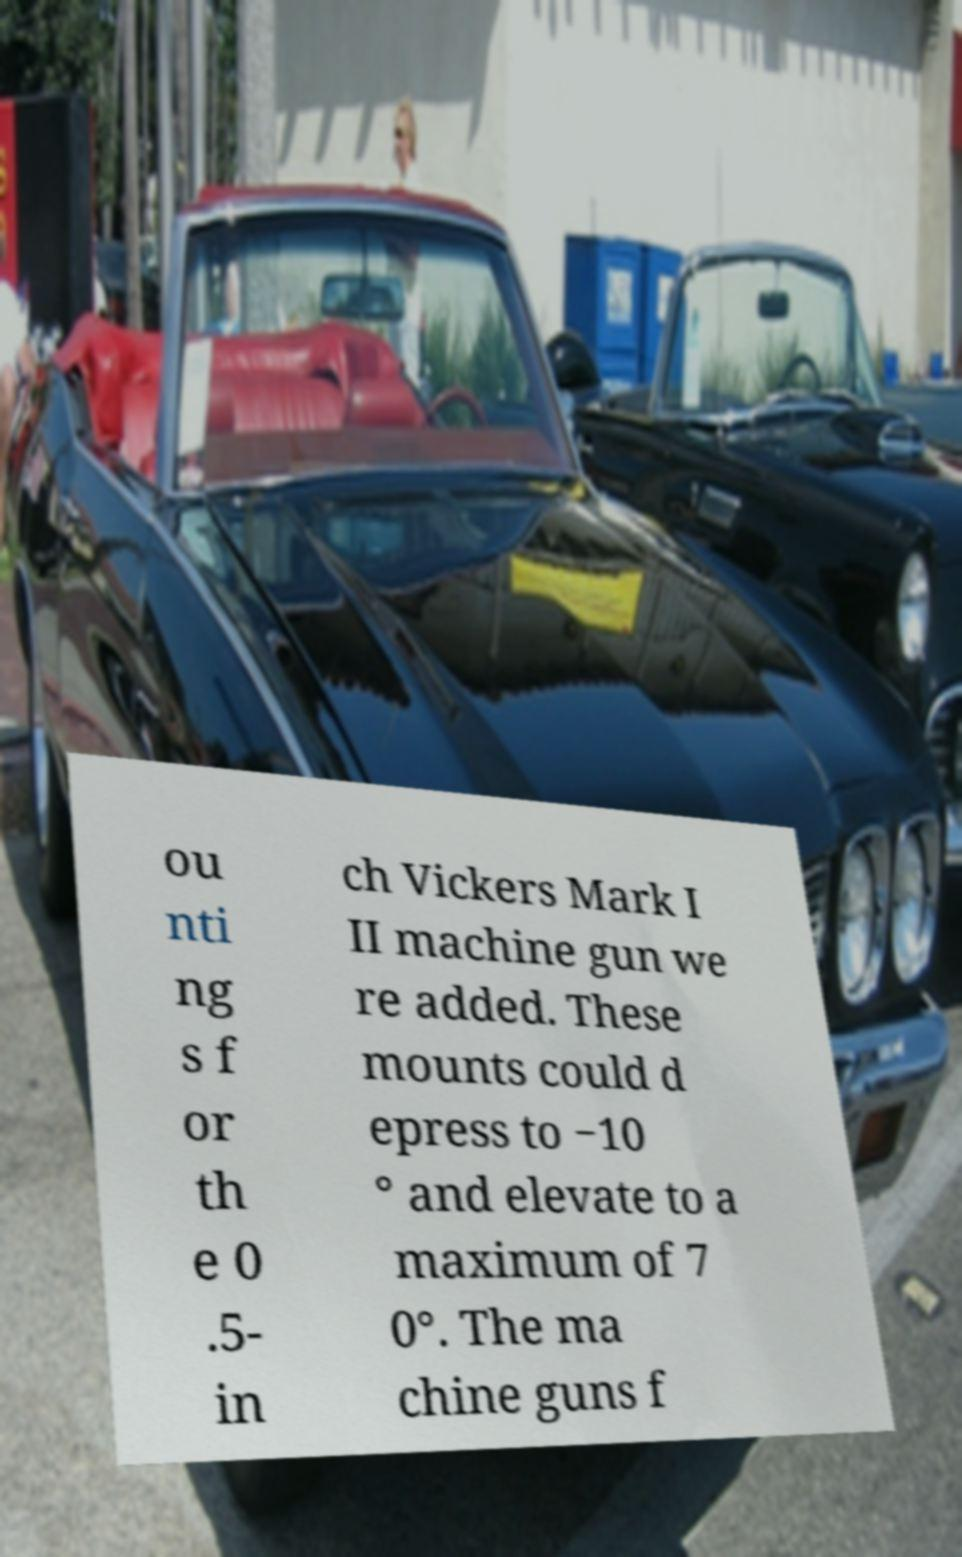There's text embedded in this image that I need extracted. Can you transcribe it verbatim? ou nti ng s f or th e 0 .5- in ch Vickers Mark I II machine gun we re added. These mounts could d epress to −10 ° and elevate to a maximum of 7 0°. The ma chine guns f 